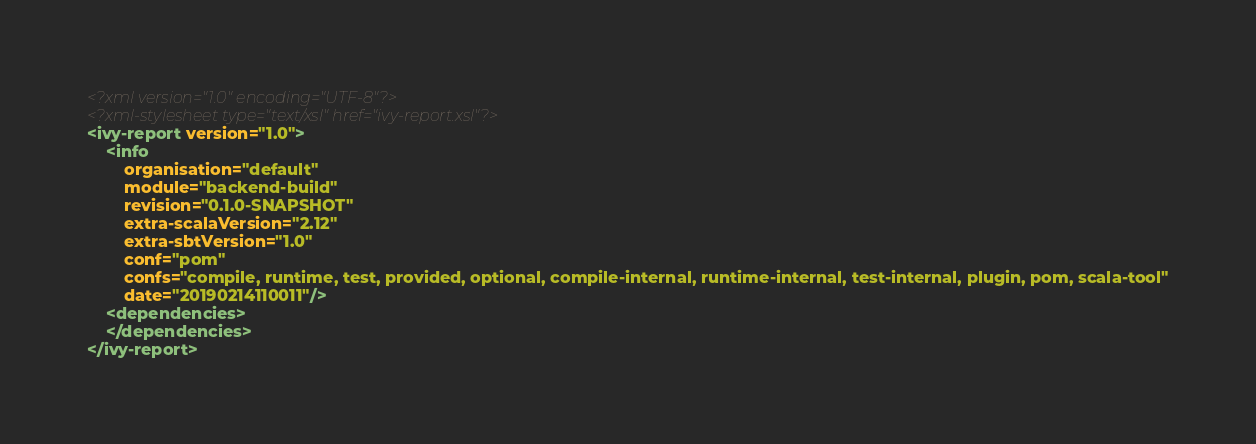Convert code to text. <code><loc_0><loc_0><loc_500><loc_500><_XML_><?xml version="1.0" encoding="UTF-8"?>
<?xml-stylesheet type="text/xsl" href="ivy-report.xsl"?>
<ivy-report version="1.0">
	<info
		organisation="default"
		module="backend-build"
		revision="0.1.0-SNAPSHOT"
		extra-scalaVersion="2.12"
		extra-sbtVersion="1.0"
		conf="pom"
		confs="compile, runtime, test, provided, optional, compile-internal, runtime-internal, test-internal, plugin, pom, scala-tool"
		date="20190214110011"/>
	<dependencies>
	</dependencies>
</ivy-report>
</code> 